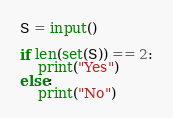Convert code to text. <code><loc_0><loc_0><loc_500><loc_500><_Python_>S = input()

if len(set(S)) == 2:
    print("Yes")
else:
    print("No")
</code> 